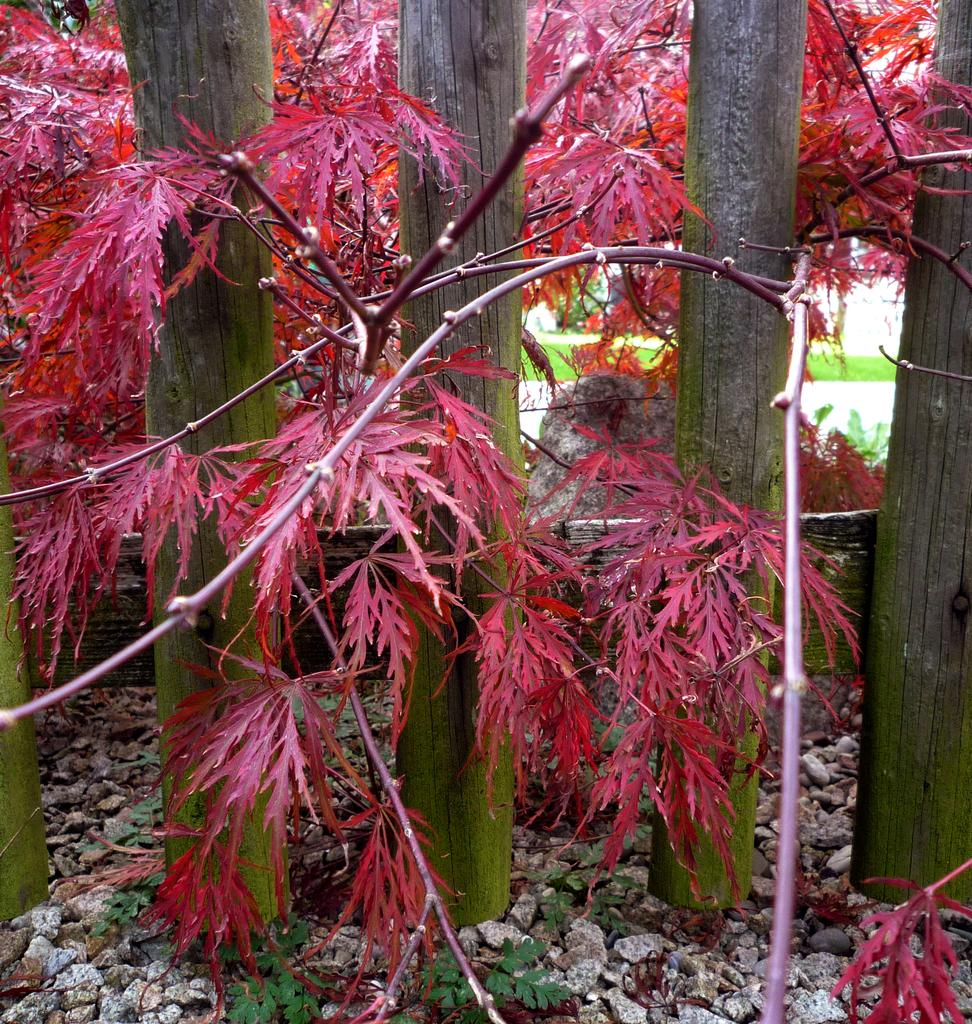What type of vegetation is present in the image? There are trees in the image. What can be found on the ground in the image? There are stones on the ground in the image. What type of barrier is visible in the image? There is a fence in the image. What type of ground cover is visible in the background of the image? There is grass on the ground in the background of the image. Can you see the harmony between the trees and the toes in the image? There are no toes present in the image, and the concept of harmony between trees and toes is not applicable. 